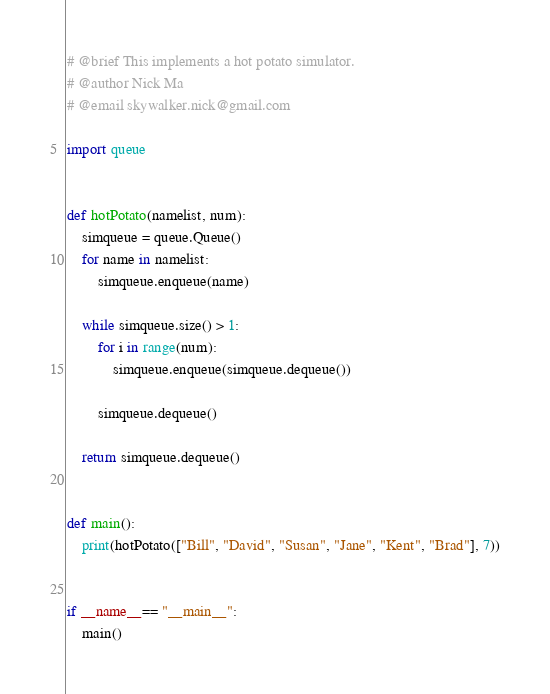<code> <loc_0><loc_0><loc_500><loc_500><_Python_># @brief This implements a hot potato simulator.
# @author Nick Ma
# @email skywalker.nick@gmail.com

import queue


def hotPotato(namelist, num):
    simqueue = queue.Queue()
    for name in namelist:
        simqueue.enqueue(name)

    while simqueue.size() > 1:
        for i in range(num):
            simqueue.enqueue(simqueue.dequeue())

        simqueue.dequeue()

    return simqueue.dequeue()


def main():
    print(hotPotato(["Bill", "David", "Susan", "Jane", "Kent", "Brad"], 7))


if __name__== "__main__":
    main()
</code> 